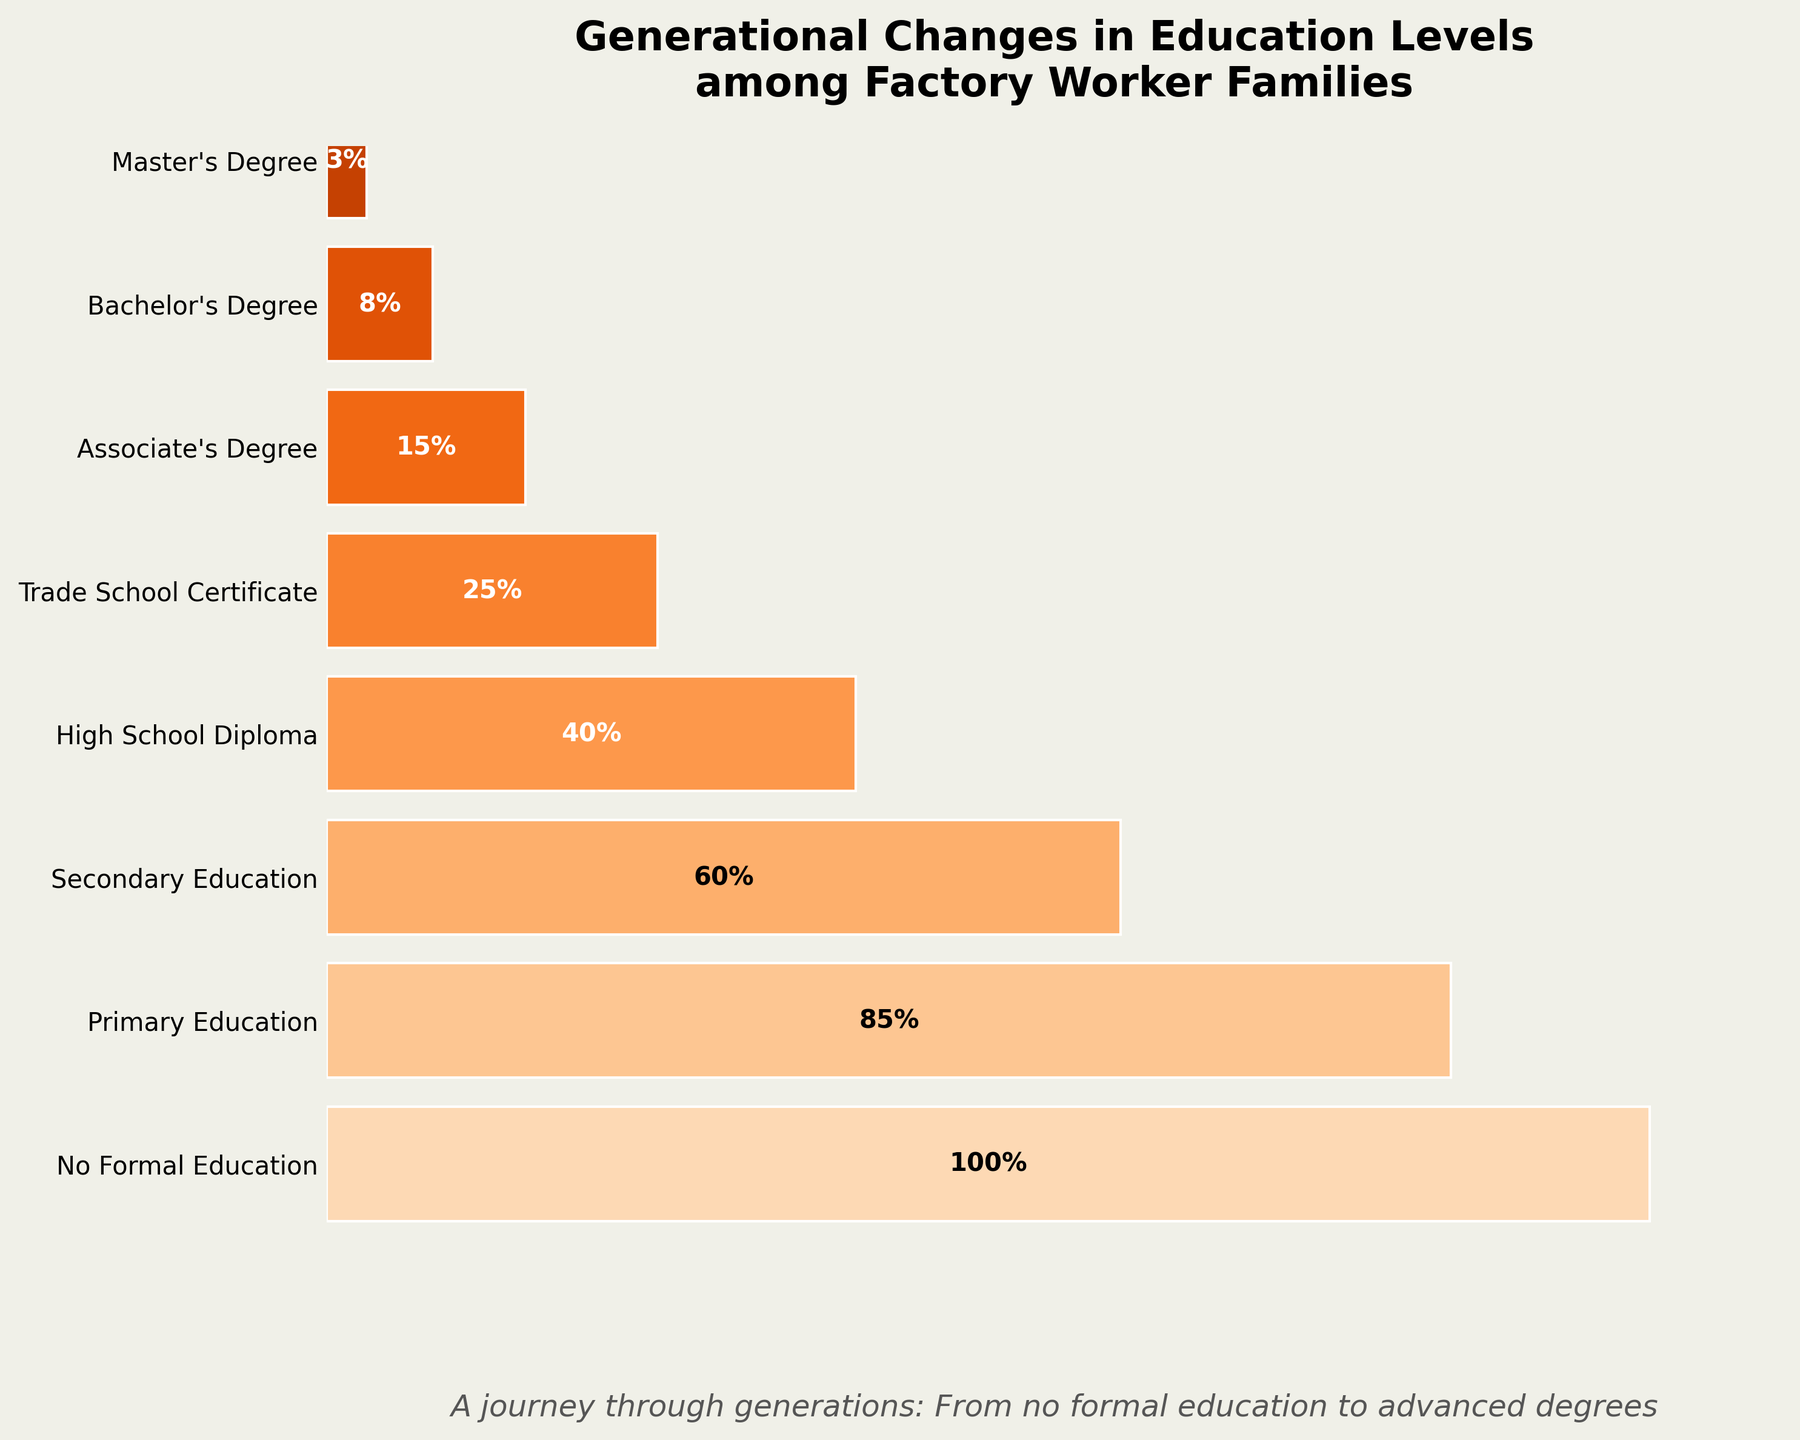what is the title of the chart? The title of the chart is located at the top and it reads "Generational Changes in Education Levels among Factory Worker Families".
Answer: Generational Changes in Education Levels among Factory Worker Families how many different education levels are shown in the chart? Count the education levels listed on the y-axis. There are eight education levels presented.
Answer: Eight which education level has the highest percentage? The education level at the top of the chart has the highest percentage at 100%. This is "No Formal Education".
Answer: No Formal Education which education level has the lowest percentage? The education level at the bottom of the chart has the lowest percentage at 3%. This is "Master's Degree".
Answer: Master's Degree how much greater is the percentage of secondary education than a bachelor's degree? The percentage of secondary education is 60%, and the percentage of a bachelor's degree is 8%. Subtracting these values gives 60% - 8% = 52%.
Answer: 52% what is the combined percentage of all tertiary education levels (associate's degree, bachelor's degree, master's degree)? The tertiary education levels are associate's degree (15%), bachelor's degree (8%), and master's degree (3%). Adding these gives 15% + 8% + 3% = 26%.
Answer: 26% what percentage of families achieve at least a trade school certificate? The smallest value representing the percentage starting from "Trade School Certificate" and continuing up is 25%.
Answer: 25% how does the percentage change from primary education to high school diploma? The percentage for primary education is 85%, and for high school diploma is 40%. The change is 85% - 40% = 45%.
Answer: 45% which education level has the largest drop in percentage compared to its preceding level? The largest drop occurs between primary education (85%) and secondary education (60%). The change is 85% - 60% = 25%.
Answer: Secondary Education explain what the funnel shape signifies in terms of generational educational attainment. The funnel shape narrows from top to bottom, indicating that the number of people achieving higher education levels reduces significantly with each generational step. The widest part at the top (100% with no formal education) shows the starting point for many generations, and as the levels of education increase, progressively fewer people attain these levels, signifying a reduction in percentages.
Answer: Attainment decreases at each subsequent level 